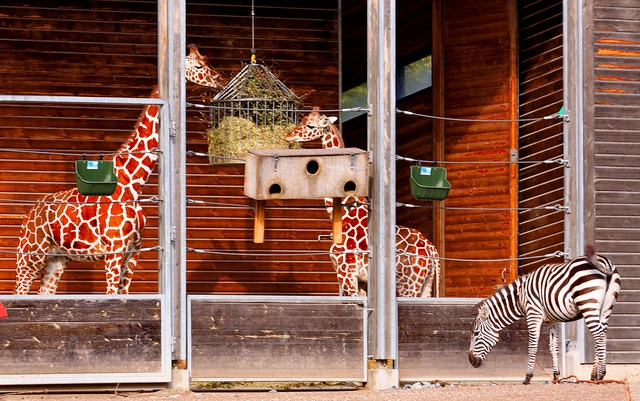Describe the objects in this image and their specific colors. I can see giraffe in black, white, brown, red, and maroon tones, zebra in black, white, maroon, and gray tones, and giraffe in black, white, brown, and tan tones in this image. 